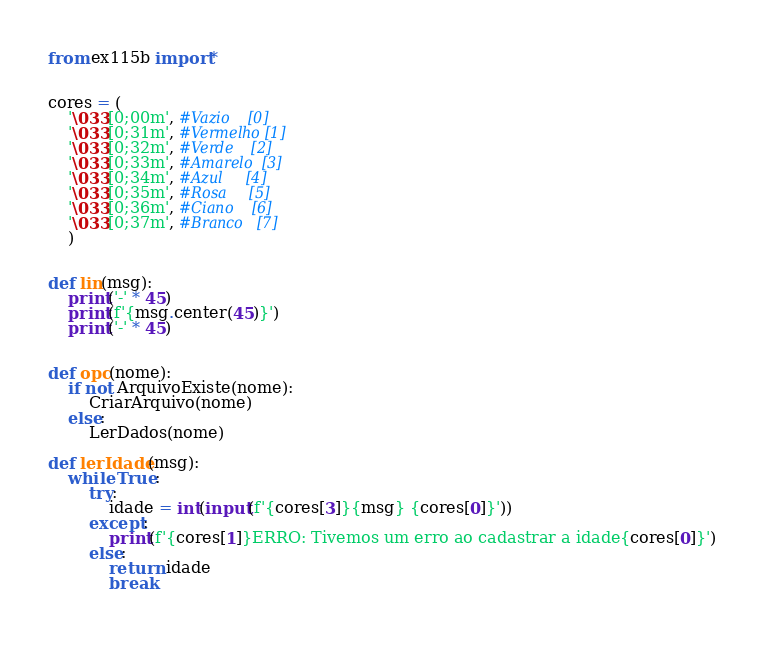<code> <loc_0><loc_0><loc_500><loc_500><_Python_>from ex115b import*


cores = (
    '\033[0;00m', #Vazio    [0]
    '\033[0;31m', #Vermelho [1] 
    '\033[0;32m', #Verde    [2] 
    '\033[0;33m', #Amarelo  [3]
    '\033[0;34m', #Azul     [4]
    '\033[0;35m', #Rosa     [5]
    '\033[0;36m', #Ciano    [6]
    '\033[0;37m', #Branco   [7]
    )


def lin(msg):
    print('-' * 45)
    print(f'{msg.center(45)}')
    print('-' * 45)


def opc(nome):
    if not ArquivoExiste(nome):
        CriarArquivo(nome)
    else:
        LerDados(nome)

def lerIdade(msg):
    while True:
        try:   
            idade = int(input(f'{cores[3]}{msg} {cores[0]}'))
        except:
            print(f'{cores[1]}ERRO: Tivemos um erro ao cadastrar a idade{cores[0]}')
        else:
            return idade
            break
    
</code> 